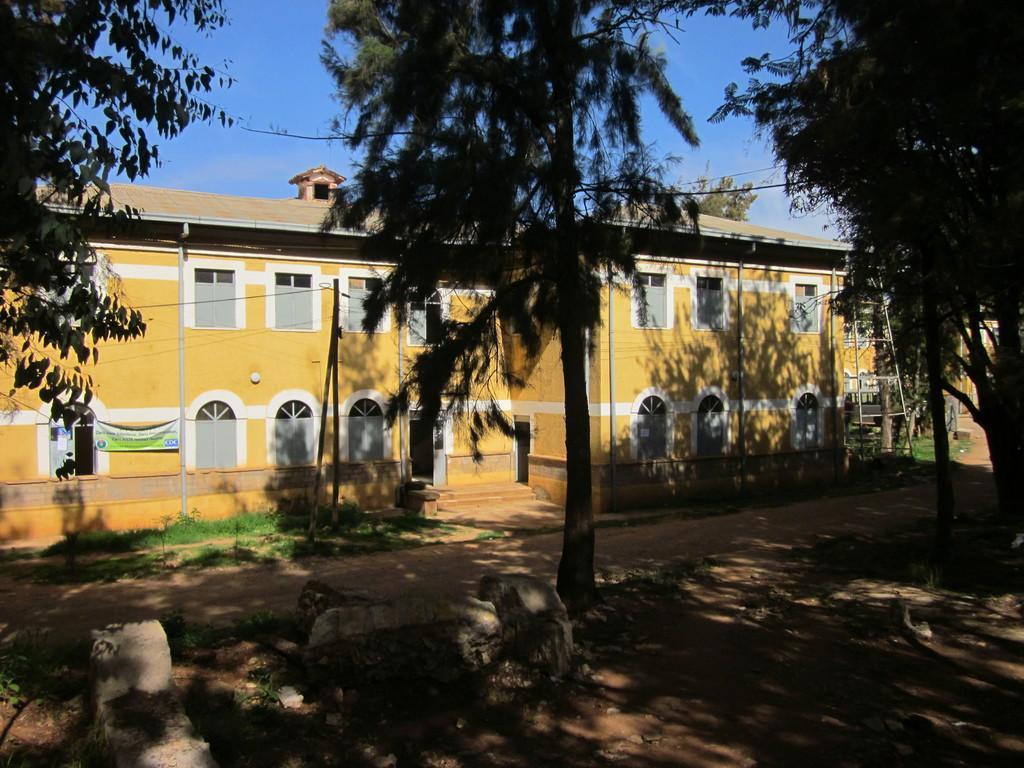Please provide a concise description of this image. In this image I can see a building,windows,banner,stairs and trees. The sky is in blue color. 